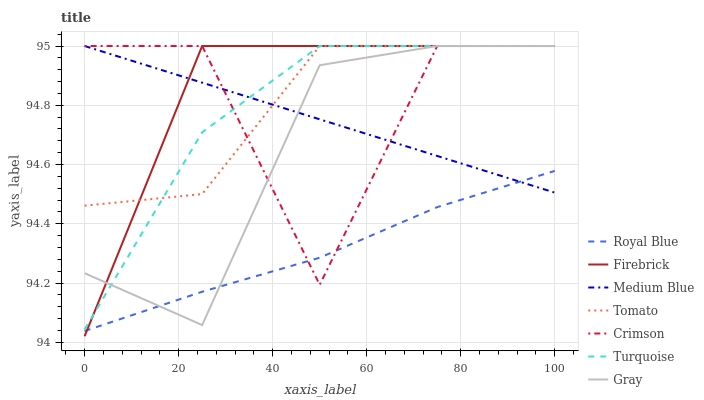Does Gray have the minimum area under the curve?
Answer yes or no. No. Does Gray have the maximum area under the curve?
Answer yes or no. No. Is Gray the smoothest?
Answer yes or no. No. Is Gray the roughest?
Answer yes or no. No. Does Gray have the lowest value?
Answer yes or no. No. Does Royal Blue have the highest value?
Answer yes or no. No. Is Royal Blue less than Turquoise?
Answer yes or no. Yes. Is Tomato greater than Royal Blue?
Answer yes or no. Yes. Does Royal Blue intersect Turquoise?
Answer yes or no. No. 